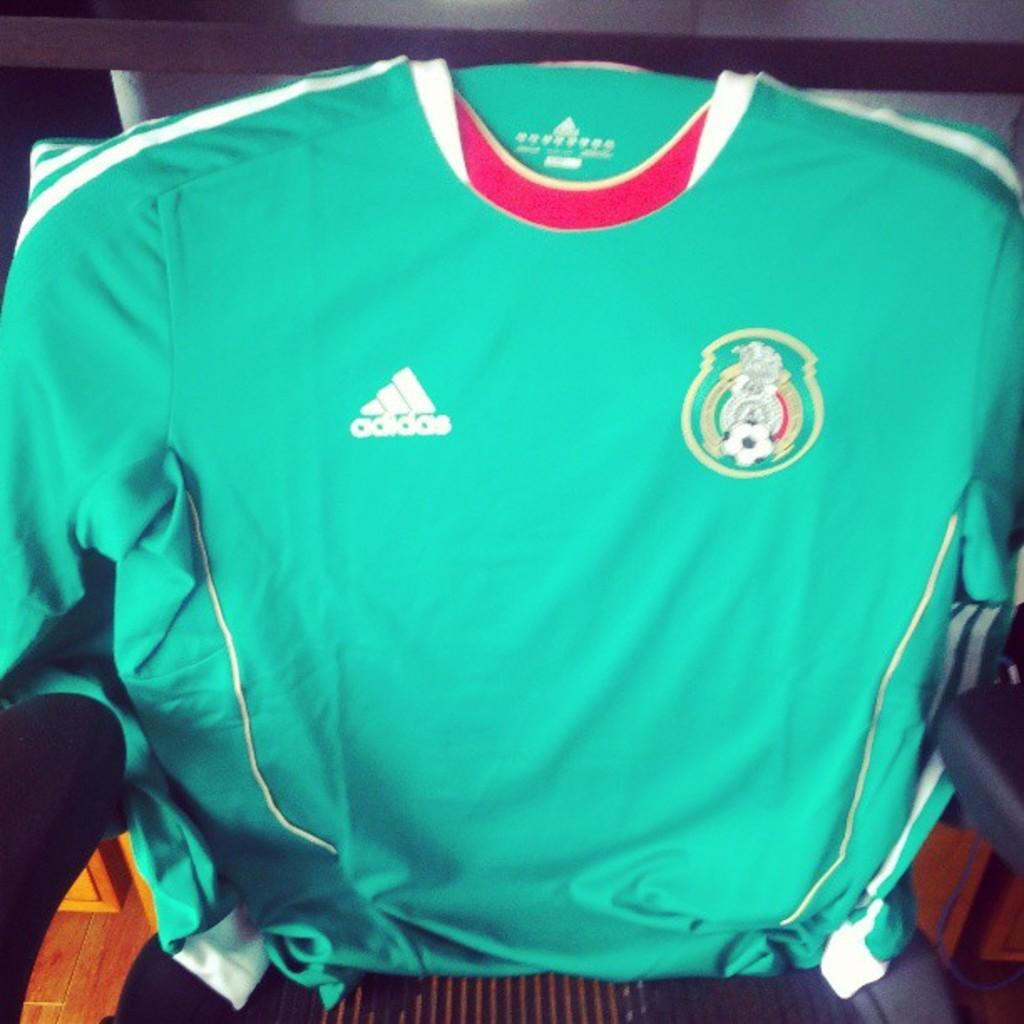<image>
Write a terse but informative summary of the picture. A green shirt for soccer made by addidas. 